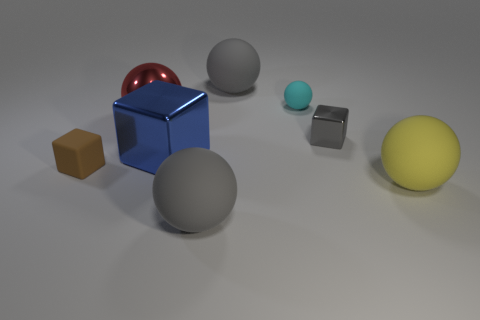Are there fewer tiny cyan objects in front of the tiny matte cube than big matte spheres that are behind the small rubber sphere?
Ensure brevity in your answer.  Yes. Does the thing that is left of the large red thing have the same shape as the big blue metallic object?
Keep it short and to the point. Yes. Are there any other things that are the same material as the big red object?
Your response must be concise. Yes. Does the large gray sphere that is in front of the yellow object have the same material as the big yellow ball?
Provide a succinct answer. Yes. There is a big yellow thing in front of the large blue block that is in front of the big gray rubber ball that is behind the large blue thing; what is its material?
Make the answer very short. Rubber. How many other objects are the same shape as the tiny gray object?
Provide a short and direct response. 2. What color is the matte thing left of the large red thing?
Provide a short and direct response. Brown. There is a gray rubber thing behind the tiny object in front of the blue metal thing; how many large gray rubber balls are to the right of it?
Your response must be concise. 0. How many brown blocks are in front of the large gray matte object in front of the small metallic cube?
Keep it short and to the point. 0. There is a big blue block; how many blue things are in front of it?
Keep it short and to the point. 0. 